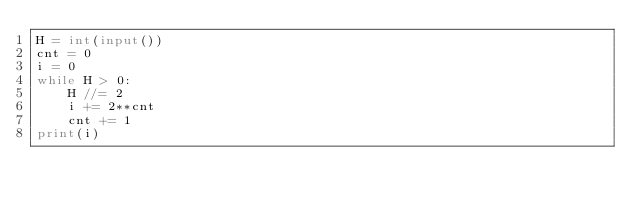<code> <loc_0><loc_0><loc_500><loc_500><_Python_>H = int(input())
cnt = 0
i = 0
while H > 0:
    H //= 2
    i += 2**cnt
    cnt += 1
print(i)</code> 